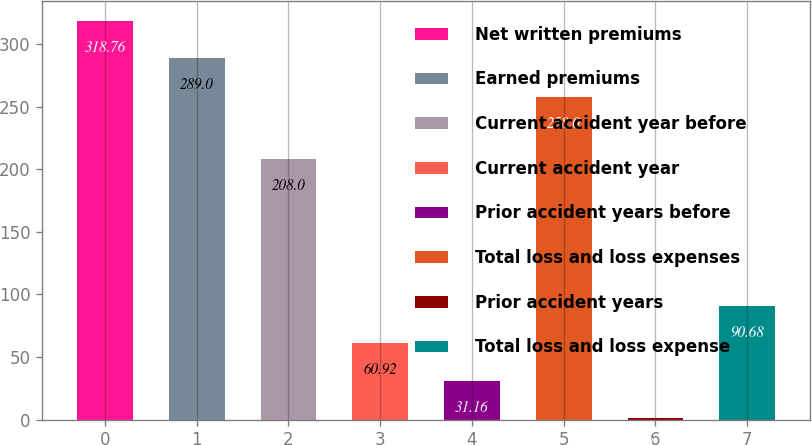Convert chart. <chart><loc_0><loc_0><loc_500><loc_500><bar_chart><fcel>Net written premiums<fcel>Earned premiums<fcel>Current accident year before<fcel>Current accident year<fcel>Prior accident years before<fcel>Total loss and loss expenses<fcel>Prior accident years<fcel>Total loss and loss expense<nl><fcel>318.76<fcel>289<fcel>208<fcel>60.92<fcel>31.16<fcel>258<fcel>1.4<fcel>90.68<nl></chart> 